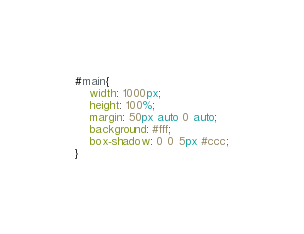Convert code to text. <code><loc_0><loc_0><loc_500><loc_500><_CSS_>#main{
    width: 1000px;
    height: 100%;
    margin: 50px auto 0 auto;
    background: #fff;
    box-shadow: 0 0 5px #ccc;
}
</code> 